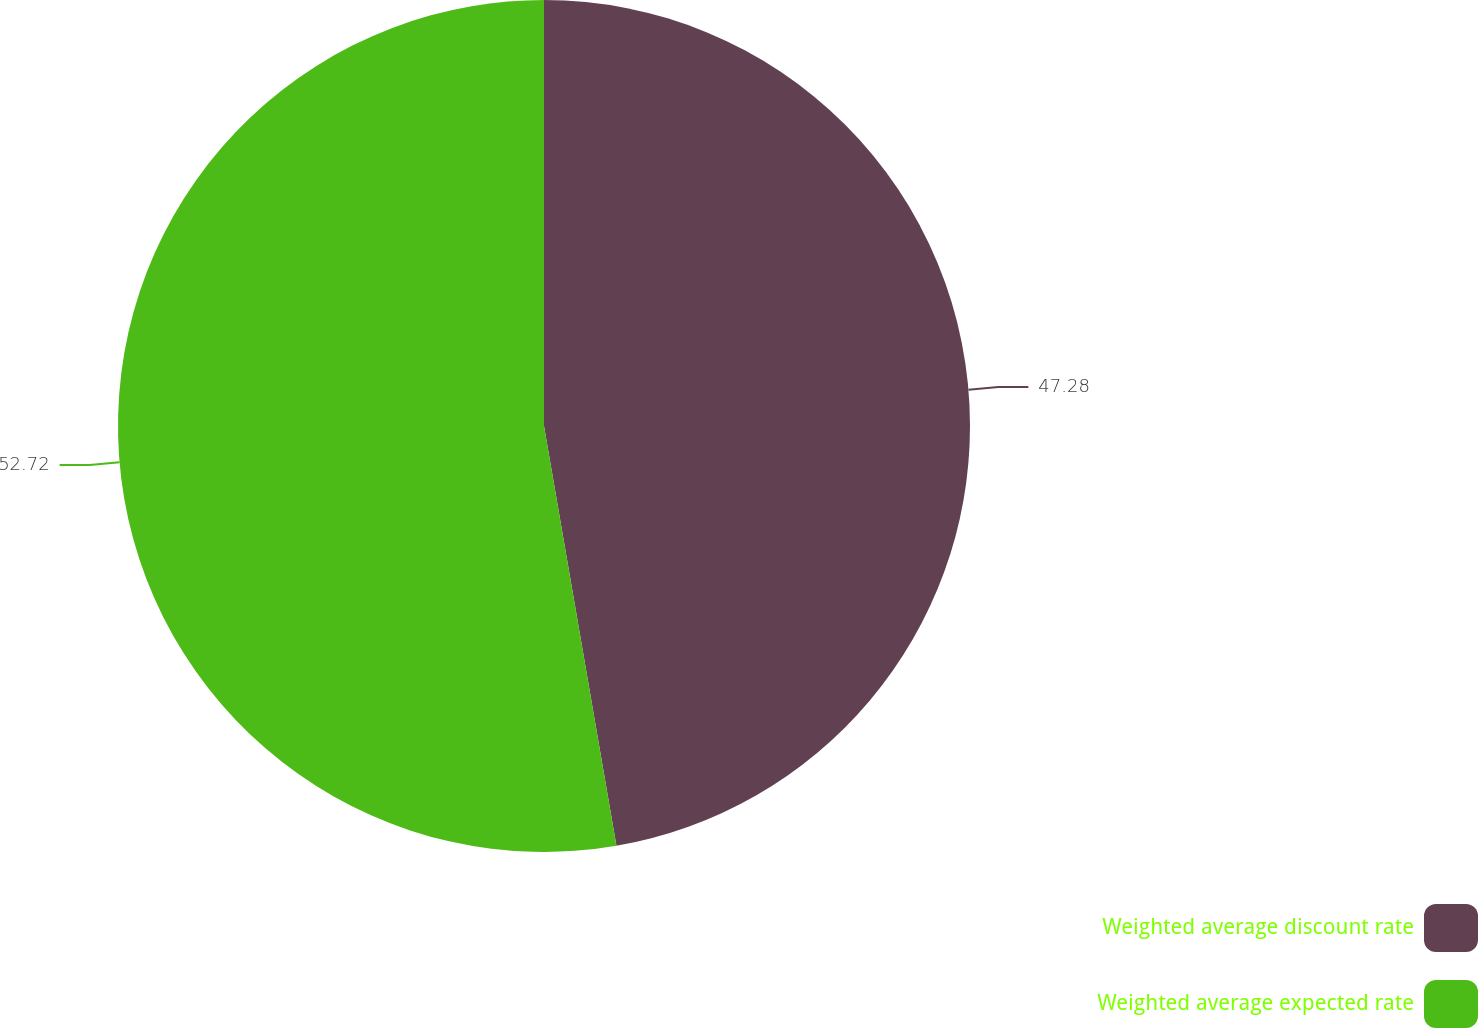Convert chart. <chart><loc_0><loc_0><loc_500><loc_500><pie_chart><fcel>Weighted average discount rate<fcel>Weighted average expected rate<nl><fcel>47.28%<fcel>52.72%<nl></chart> 